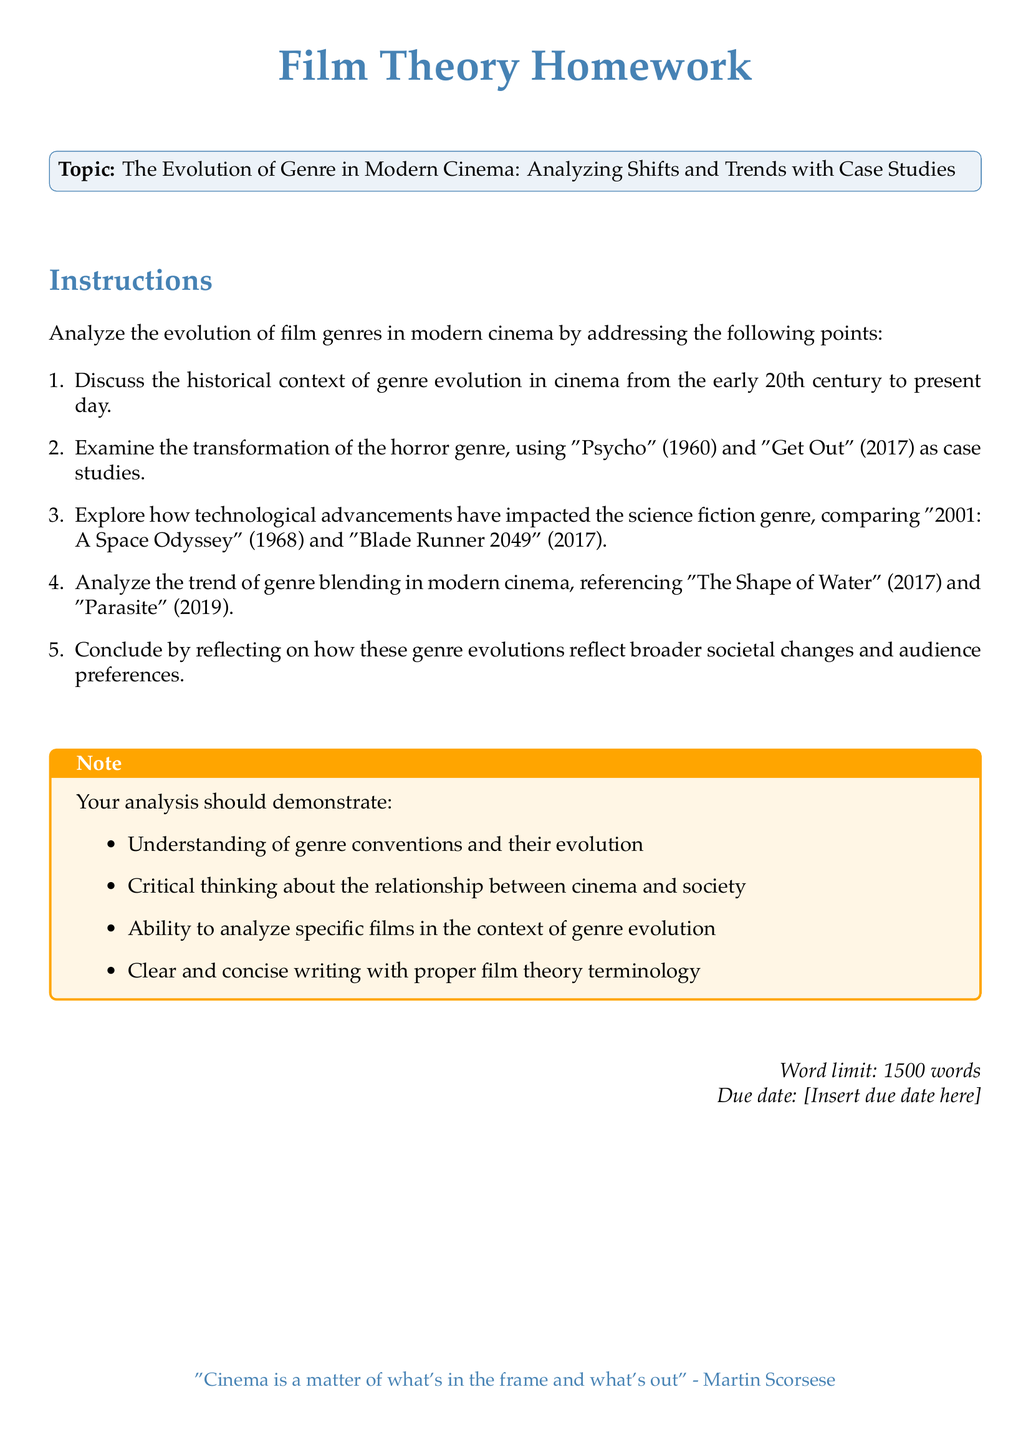What is the topic of the homework? The topic of the homework is stated in the document, which is about the evolution of film genres in modern cinema.
Answer: The Evolution of Genre in Modern Cinema: Analyzing Shifts and Trends with Case Studies How many case studies are mentioned in the document? The document lists four case studies pertaining to specific films in different genres.
Answer: Four What film represents the horror genre in the homework? The document specifies films used as case studies, including one from the horror genre.
Answer: Psycho Which two films are compared regarding technological advancements in the science fiction genre? The document explicitly mentions two films for comparison under technological advancements.
Answer: 2001: A Space Odyssey and Blade Runner 2049 What is the expected word limit for the analysis? The document provides a specific word limit for the homework assignment.
Answer: 1500 words What color is used for the main text headings? The document describes a specific color for the headings within the text.
Answer: Maincolor What does the note in the document emphasize? The note highlights critical components that should be demonstrated in the analysis based on the document content.
Answer: Understanding of genre conventions and their evolution When is the homework due? The document states that a due date is required to be inserted, indicating when the homework should be submitted.
Answer: [Insert due date here] 